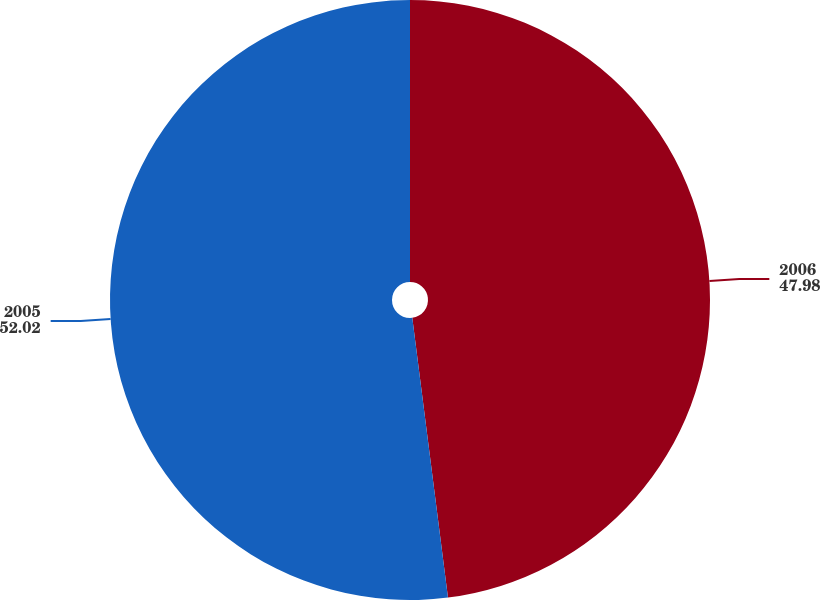Convert chart. <chart><loc_0><loc_0><loc_500><loc_500><pie_chart><fcel>2006<fcel>2005<nl><fcel>47.98%<fcel>52.02%<nl></chart> 